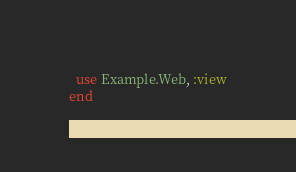<code> <loc_0><loc_0><loc_500><loc_500><_Elixir_>  use Example.Web, :view
end
</code> 